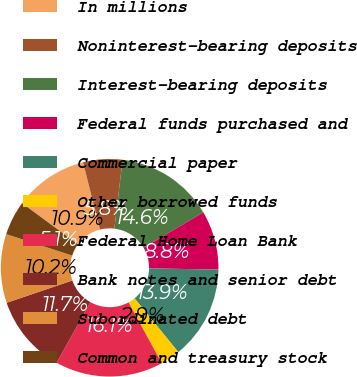Convert chart. <chart><loc_0><loc_0><loc_500><loc_500><pie_chart><fcel>In millions<fcel>Noninterest-bearing deposits<fcel>Interest-bearing deposits<fcel>Federal funds purchased and<fcel>Commercial paper<fcel>Other borrowed funds<fcel>Federal Home Loan Bank<fcel>Bank notes and senior debt<fcel>Subordinated debt<fcel>Common and treasury stock<nl><fcel>10.95%<fcel>5.84%<fcel>14.6%<fcel>8.76%<fcel>13.87%<fcel>2.92%<fcel>16.06%<fcel>11.68%<fcel>10.22%<fcel>5.11%<nl></chart> 